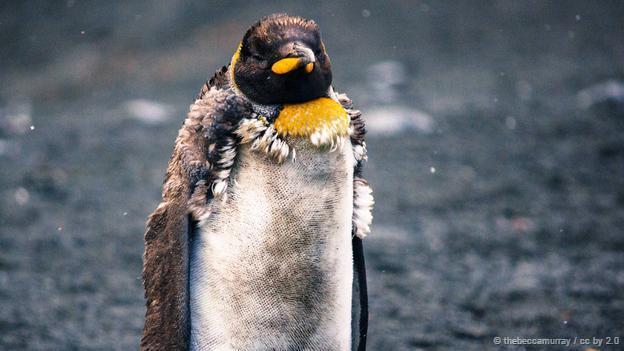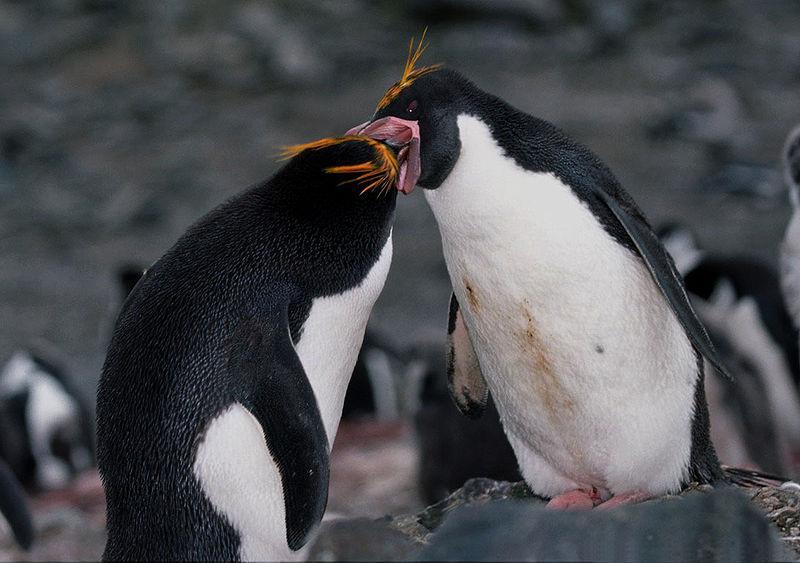The first image is the image on the left, the second image is the image on the right. For the images shown, is this caption "There is exactly one seal." true? Answer yes or no. No. The first image is the image on the left, the second image is the image on the right. Given the left and right images, does the statement "a penguin has molting feathers" hold true? Answer yes or no. Yes. 